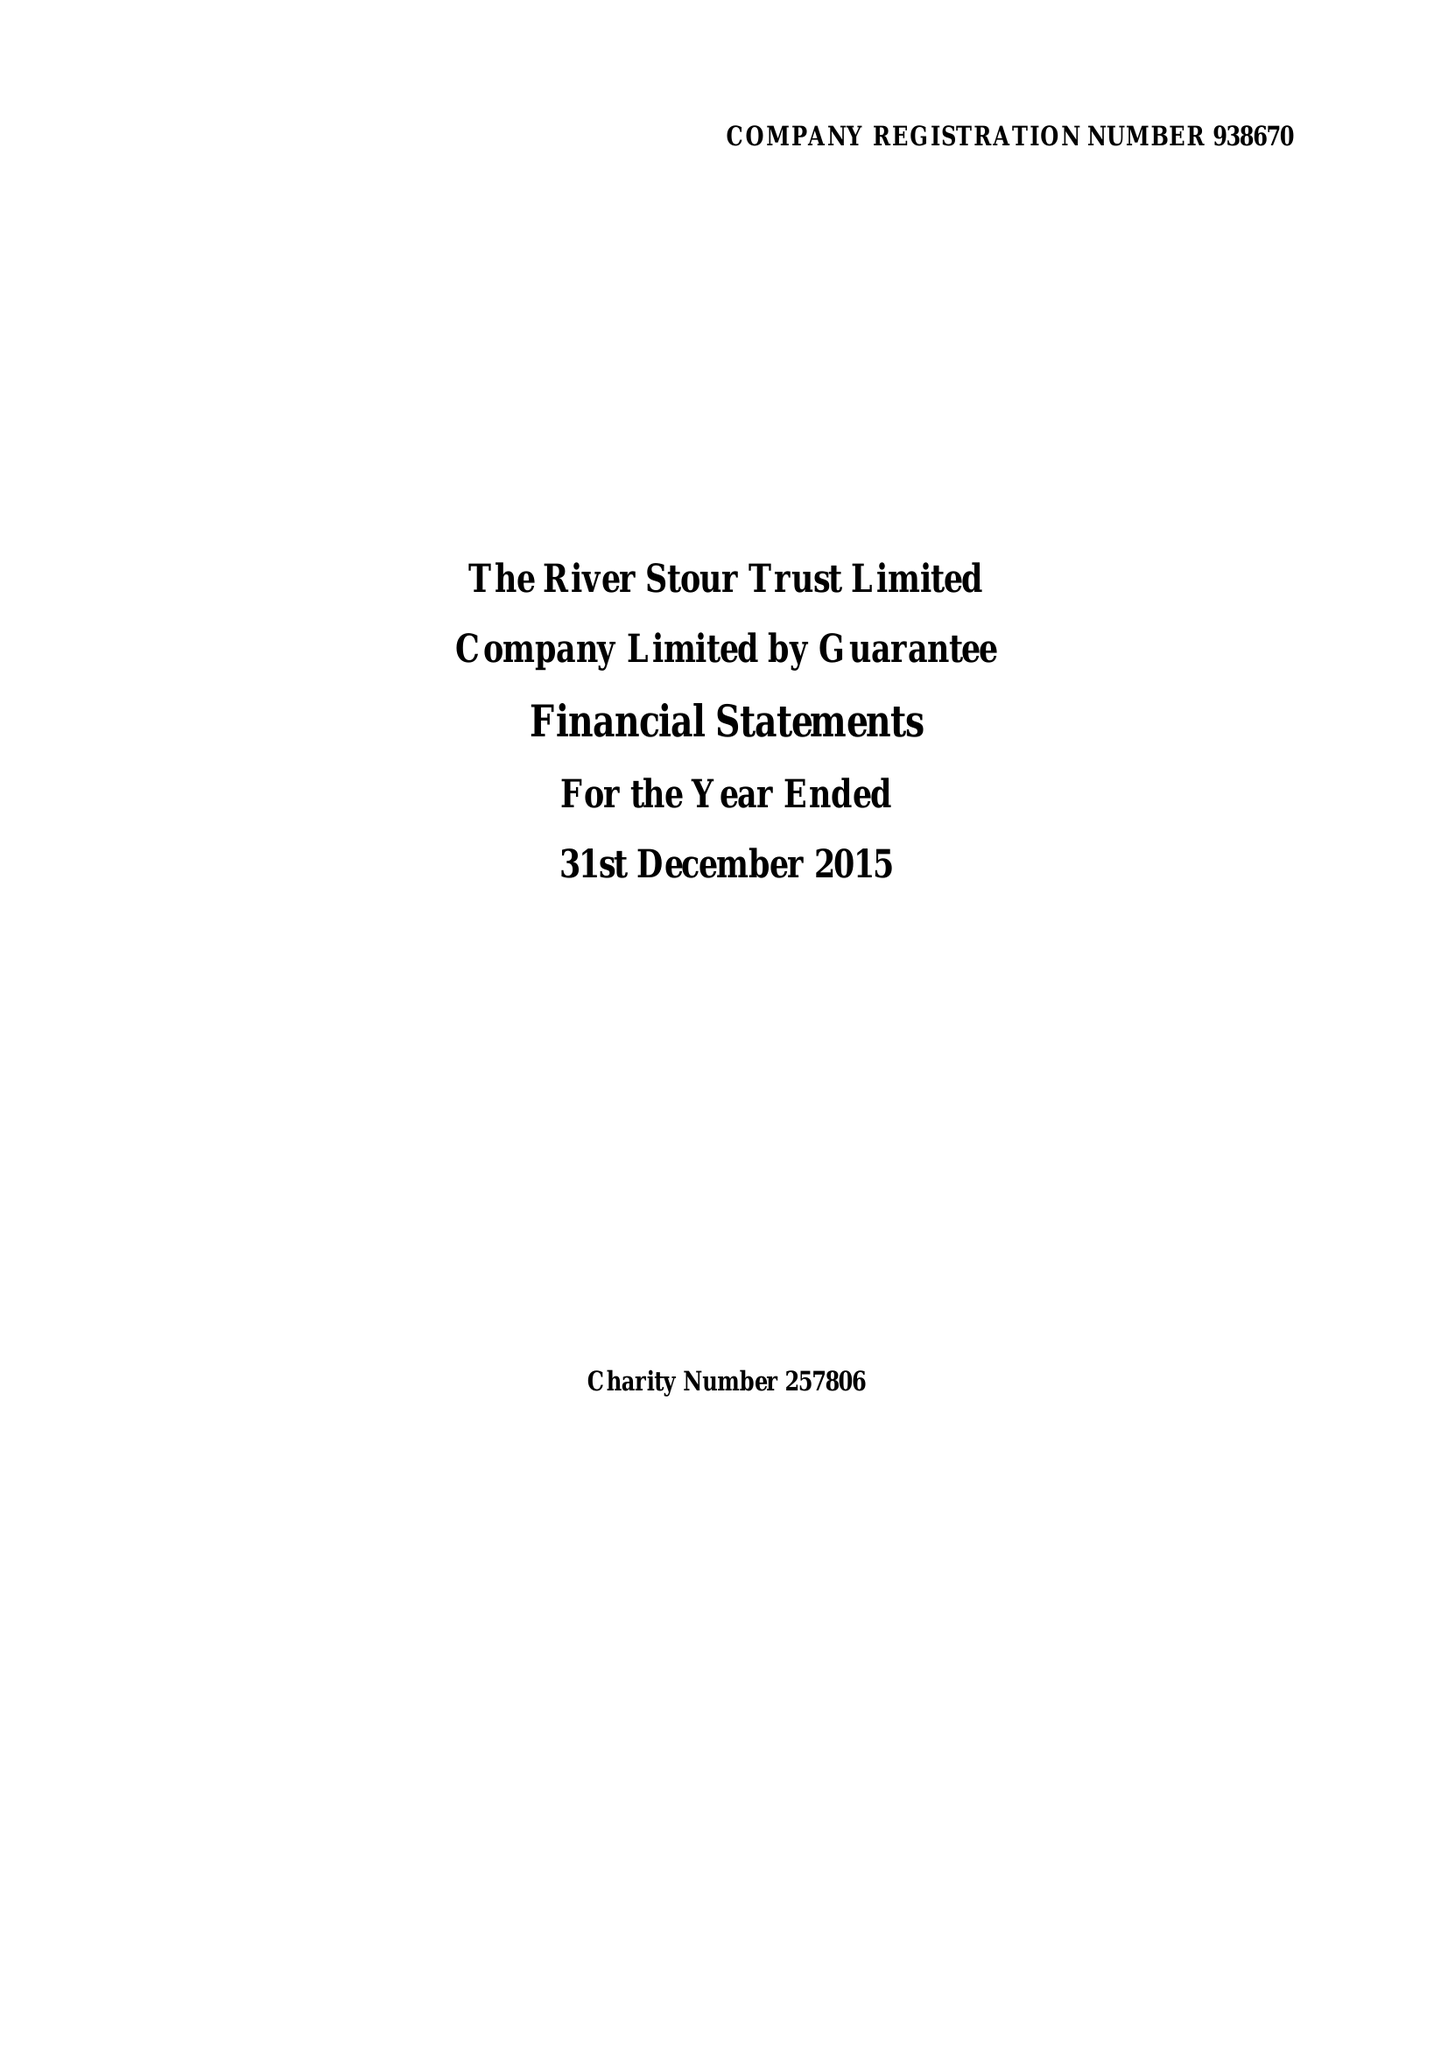What is the value for the spending_annually_in_british_pounds?
Answer the question using a single word or phrase. 98639.00 